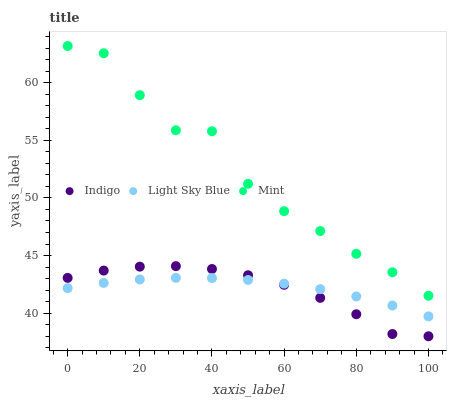Does Indigo have the minimum area under the curve?
Answer yes or no. Yes. Does Mint have the maximum area under the curve?
Answer yes or no. Yes. Does Light Sky Blue have the minimum area under the curve?
Answer yes or no. No. Does Light Sky Blue have the maximum area under the curve?
Answer yes or no. No. Is Light Sky Blue the smoothest?
Answer yes or no. Yes. Is Mint the roughest?
Answer yes or no. Yes. Is Indigo the smoothest?
Answer yes or no. No. Is Indigo the roughest?
Answer yes or no. No. Does Indigo have the lowest value?
Answer yes or no. Yes. Does Light Sky Blue have the lowest value?
Answer yes or no. No. Does Mint have the highest value?
Answer yes or no. Yes. Does Indigo have the highest value?
Answer yes or no. No. Is Light Sky Blue less than Mint?
Answer yes or no. Yes. Is Mint greater than Indigo?
Answer yes or no. Yes. Does Light Sky Blue intersect Indigo?
Answer yes or no. Yes. Is Light Sky Blue less than Indigo?
Answer yes or no. No. Is Light Sky Blue greater than Indigo?
Answer yes or no. No. Does Light Sky Blue intersect Mint?
Answer yes or no. No. 